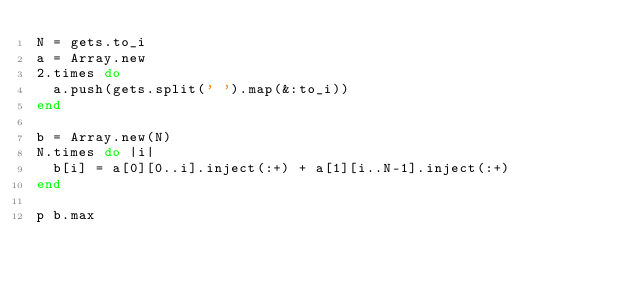<code> <loc_0><loc_0><loc_500><loc_500><_Ruby_>N = gets.to_i
a = Array.new
2.times do
  a.push(gets.split(' ').map(&:to_i))
end

b = Array.new(N)
N.times do |i|
  b[i] = a[0][0..i].inject(:+) + a[1][i..N-1].inject(:+)
end

p b.max</code> 